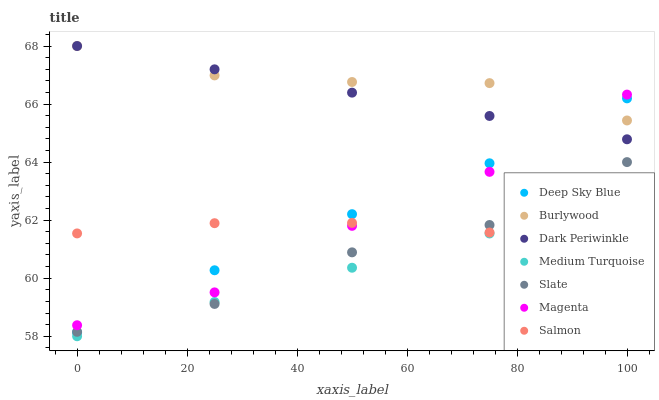Does Medium Turquoise have the minimum area under the curve?
Answer yes or no. Yes. Does Burlywood have the maximum area under the curve?
Answer yes or no. Yes. Does Slate have the minimum area under the curve?
Answer yes or no. No. Does Slate have the maximum area under the curve?
Answer yes or no. No. Is Dark Periwinkle the smoothest?
Answer yes or no. Yes. Is Slate the roughest?
Answer yes or no. Yes. Is Burlywood the smoothest?
Answer yes or no. No. Is Burlywood the roughest?
Answer yes or no. No. Does Medium Turquoise have the lowest value?
Answer yes or no. Yes. Does Slate have the lowest value?
Answer yes or no. No. Does Dark Periwinkle have the highest value?
Answer yes or no. Yes. Does Slate have the highest value?
Answer yes or no. No. Is Salmon less than Burlywood?
Answer yes or no. Yes. Is Burlywood greater than Medium Turquoise?
Answer yes or no. Yes. Does Deep Sky Blue intersect Slate?
Answer yes or no. Yes. Is Deep Sky Blue less than Slate?
Answer yes or no. No. Is Deep Sky Blue greater than Slate?
Answer yes or no. No. Does Salmon intersect Burlywood?
Answer yes or no. No. 